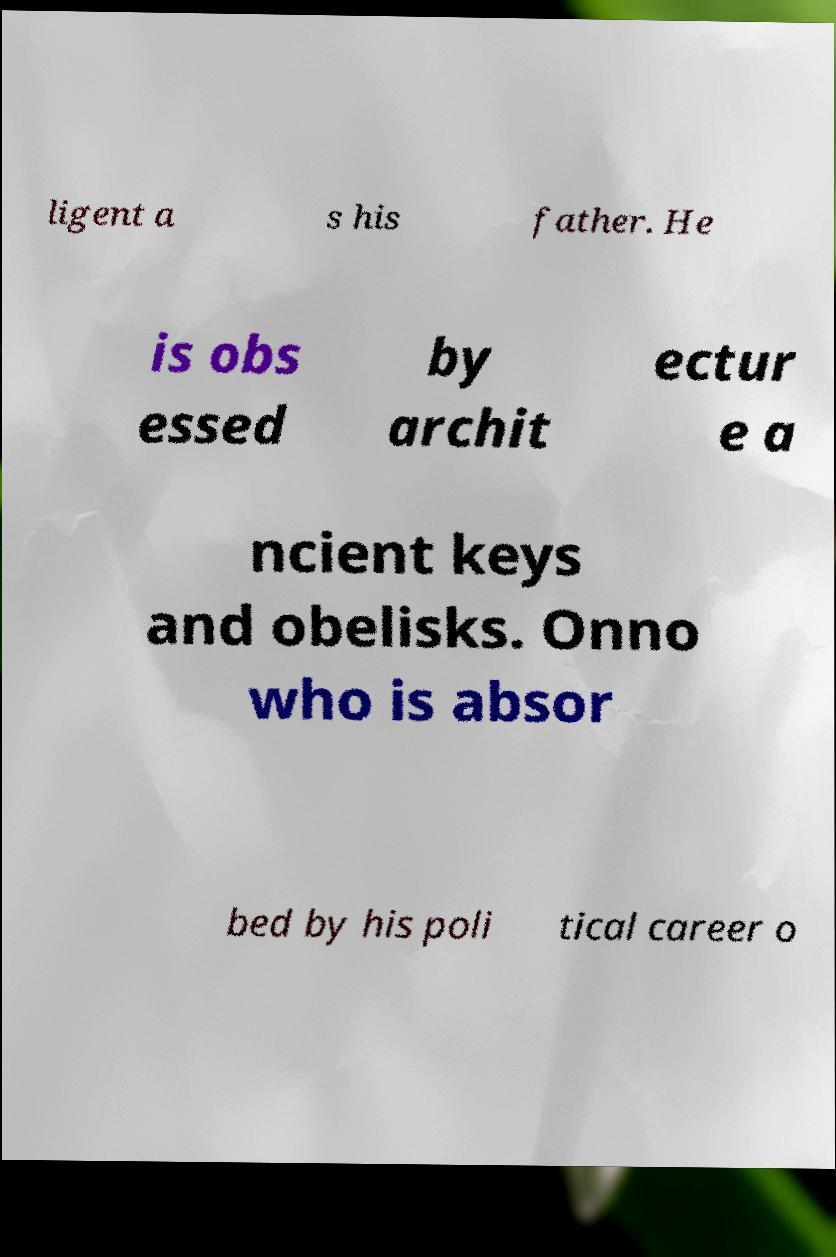Can you read and provide the text displayed in the image?This photo seems to have some interesting text. Can you extract and type it out for me? ligent a s his father. He is obs essed by archit ectur e a ncient keys and obelisks. Onno who is absor bed by his poli tical career o 